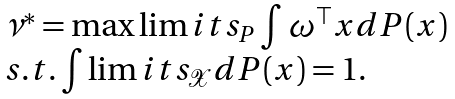<formula> <loc_0><loc_0><loc_500><loc_500>\begin{array} { l } \nu ^ { * } = \max \lim i t s _ { P } \int \omega ^ { \top } x d P ( x ) \\ s . t . \int \lim i t s _ { \mathcal { X } } d P ( x ) = 1 . \\ \end{array}</formula> 